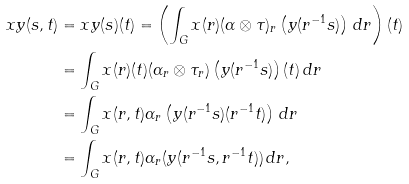<formula> <loc_0><loc_0><loc_500><loc_500>x y ( s , t ) & = x y ( s ) ( t ) = \left ( \int _ { G } x ( r ) ( \alpha \otimes \tau ) _ { r } \left ( y ( r ^ { - 1 } s ) \right ) \, d r \right ) ( t ) \\ & = \int _ { G } x ( r ) ( t ) ( \alpha _ { r } \otimes \tau _ { r } ) \left ( y ( r ^ { - 1 } s ) \right ) ( t ) \, d r \\ & = \int _ { G } x ( r , t ) \alpha _ { r } \left ( y ( r ^ { - 1 } s ) ( r ^ { - 1 } t ) \right ) \, d r \\ & = \int _ { G } x ( r , t ) \alpha _ { r } ( y ( r ^ { - 1 } s , r ^ { - 1 } t ) ) \, d r ,</formula> 